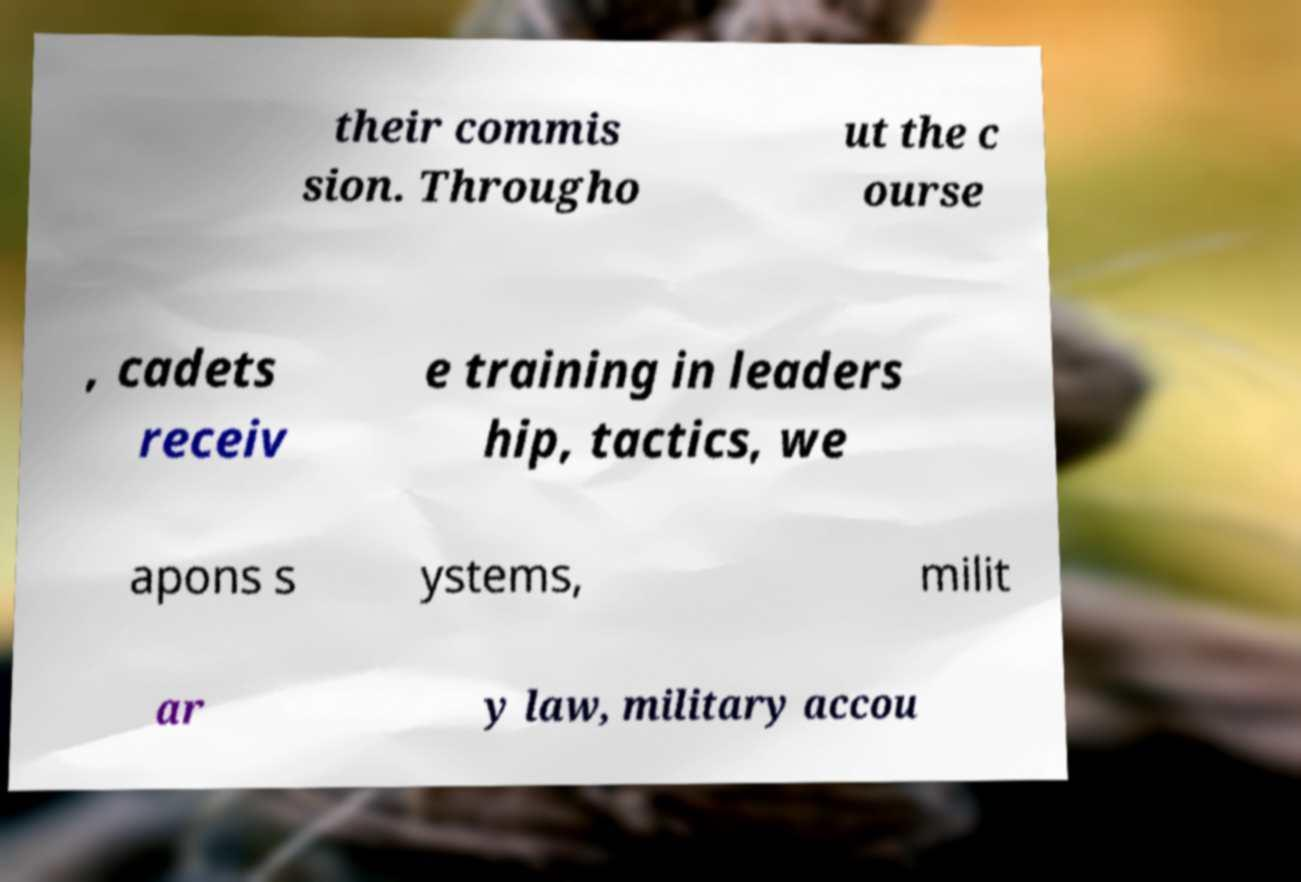Could you assist in decoding the text presented in this image and type it out clearly? their commis sion. Througho ut the c ourse , cadets receiv e training in leaders hip, tactics, we apons s ystems, milit ar y law, military accou 